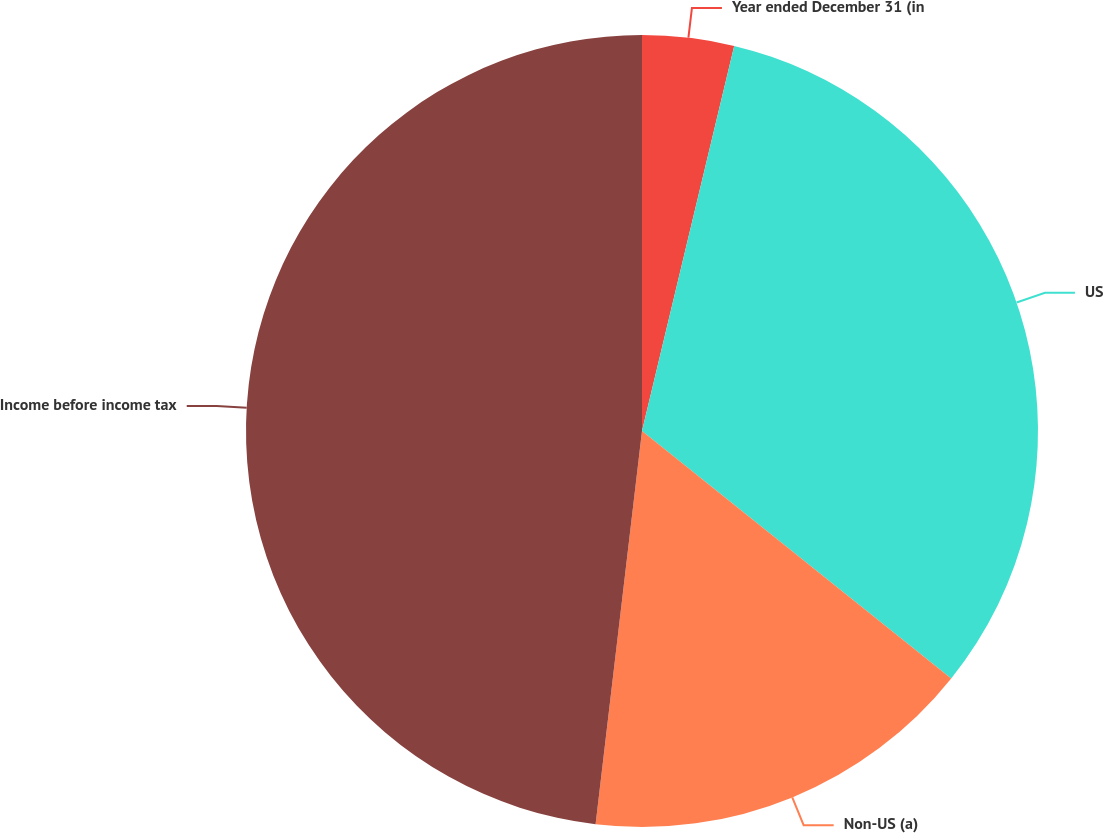Convert chart to OTSL. <chart><loc_0><loc_0><loc_500><loc_500><pie_chart><fcel>Year ended December 31 (in<fcel>US<fcel>Non-US (a)<fcel>Income before income tax<nl><fcel>3.74%<fcel>32.0%<fcel>16.13%<fcel>48.13%<nl></chart> 